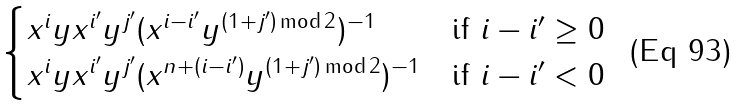Convert formula to latex. <formula><loc_0><loc_0><loc_500><loc_500>\begin{cases} x ^ { i } y x ^ { i ^ { \prime } } y ^ { j ^ { \prime } } ( x ^ { i - i ^ { \prime } } y ^ { ( 1 + j ^ { \prime } ) \, \text {mod} \, 2 } ) ^ { - 1 } & \text {if $i-i^{\prime}\geq 0$} \\ x ^ { i } y x ^ { i ^ { \prime } } y ^ { j ^ { \prime } } ( x ^ { n + ( i - i ^ { \prime } ) } y ^ { ( 1 + j ^ { \prime } ) \, \text {mod} \, 2 } ) ^ { - 1 } & \text {if $i-i^{\prime}< 0$} \end{cases}</formula> 